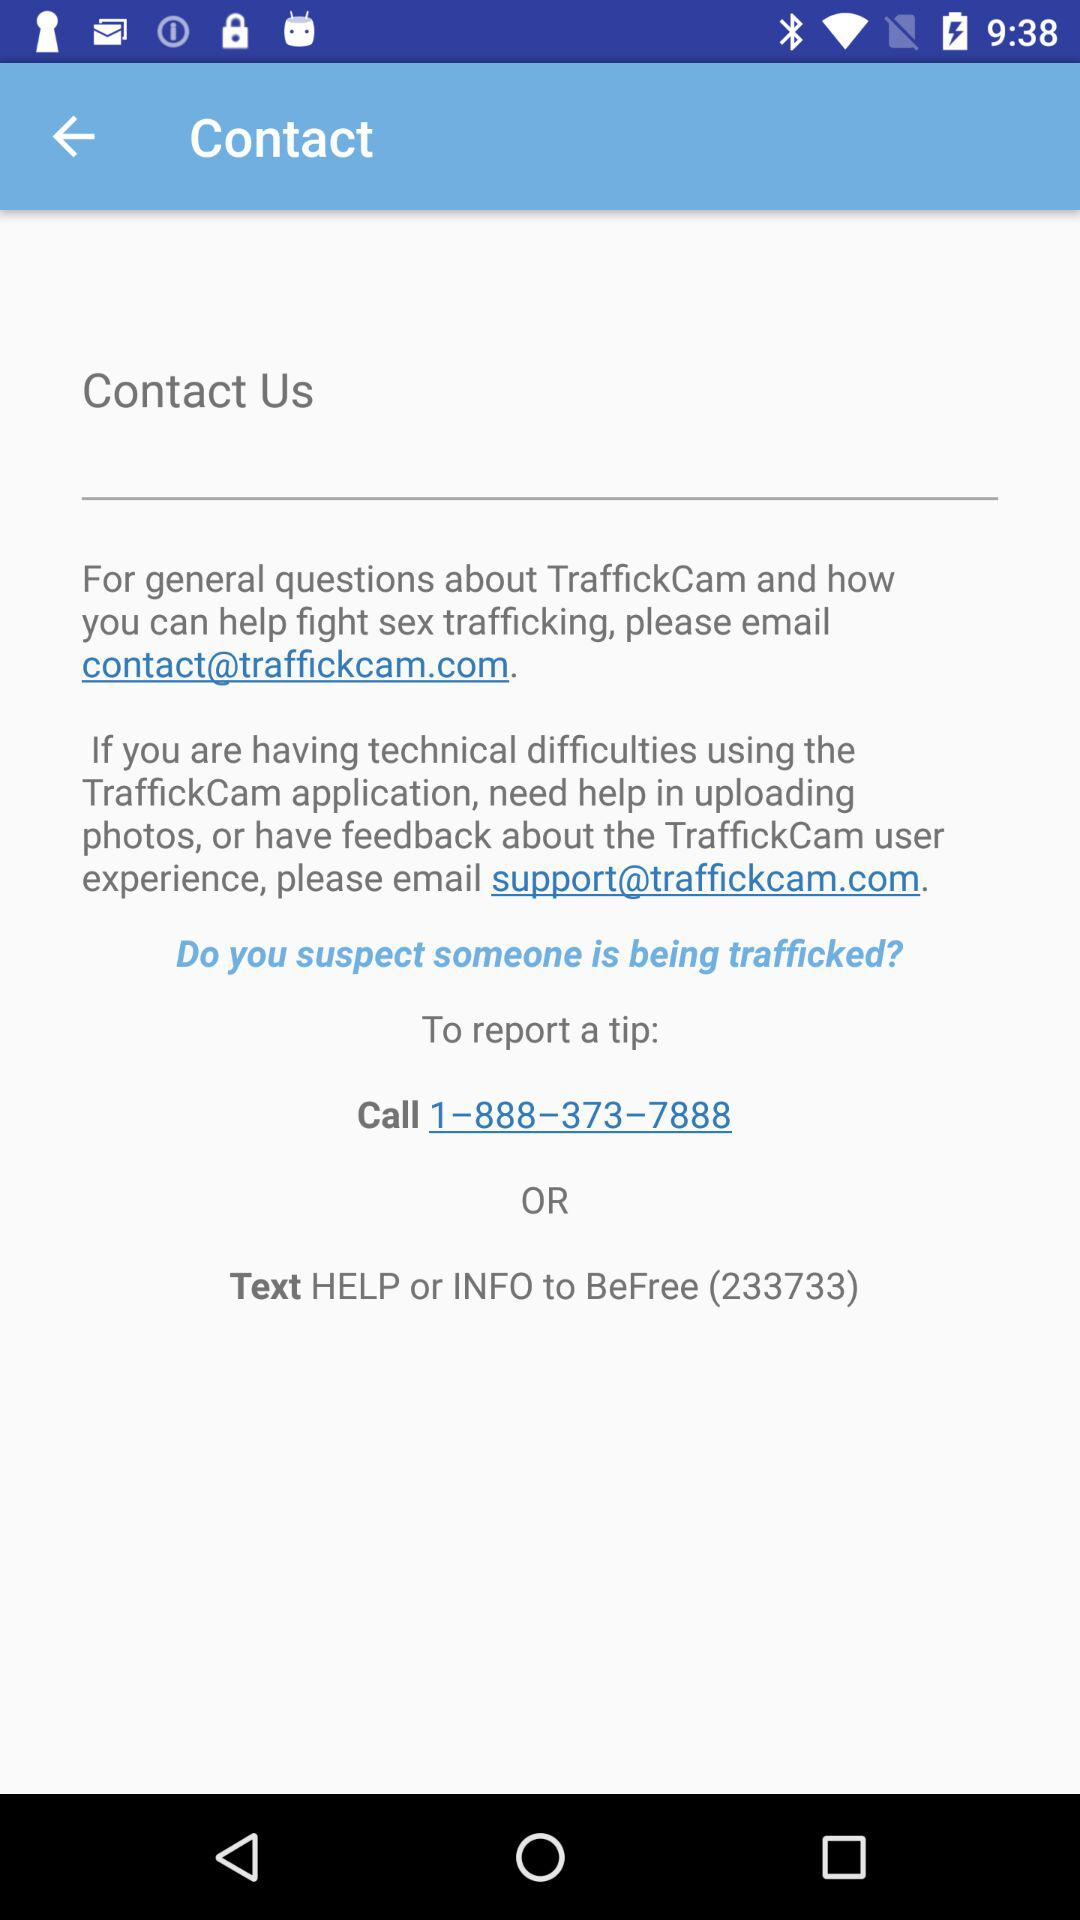What is the contact number? The contact number is 1-888-373-7888. 